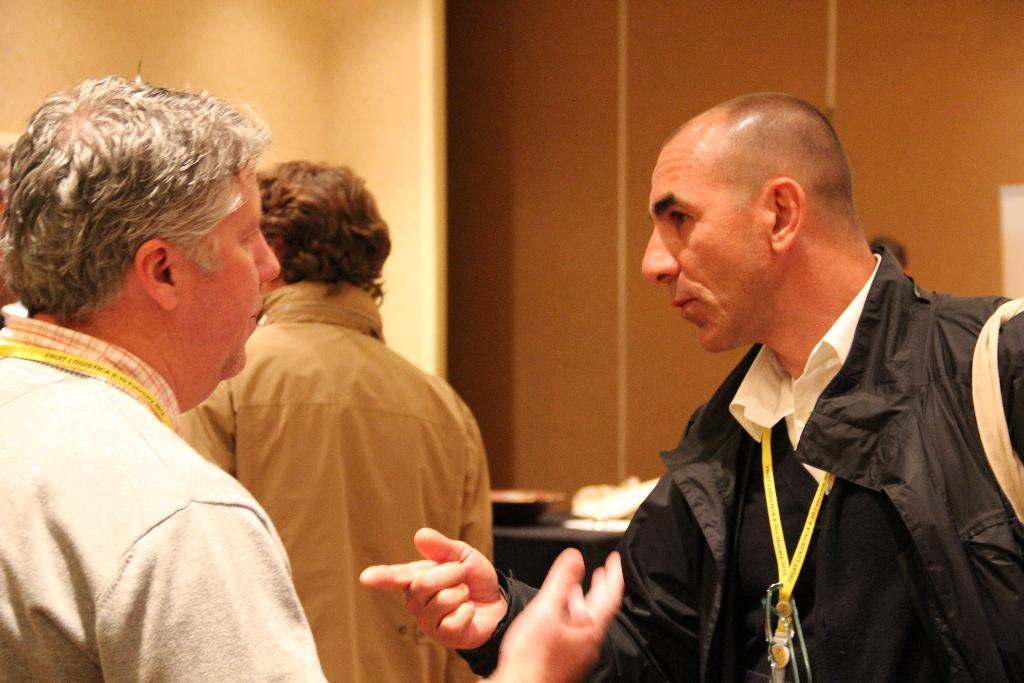How many people are present in the image? There are three people in the image, including two men and another person in the middle. What type of wood is being used to make the quilt in the image? There is no quilt or wood present in the image; it features two men and another person in the middle. 